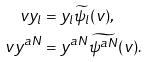Convert formula to latex. <formula><loc_0><loc_0><loc_500><loc_500>v y _ { l } & = y _ { l } \widetilde { \psi _ { l } } ( v ) , \\ v y ^ { a N } & = y ^ { a N } \widetilde { \psi ^ { a N } } ( v ) .</formula> 